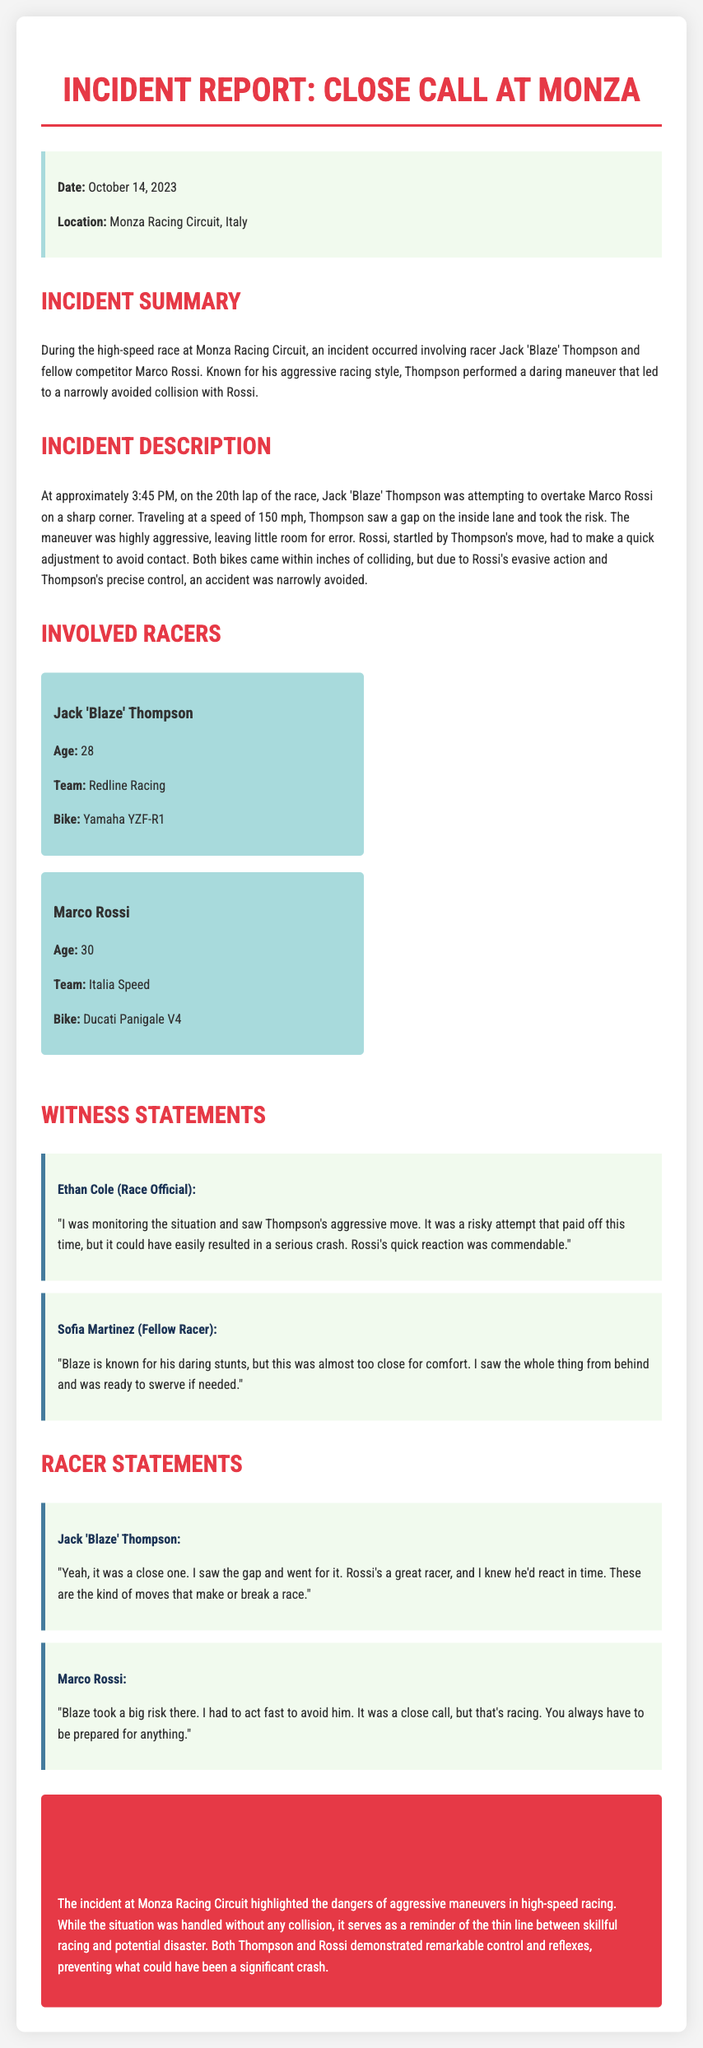What was the date of the incident? The date of the incident is explicitly mentioned in the document as October 14, 2023.
Answer: October 14, 2023 Who performed the aggressive maneuver? The report states that Jack 'Blaze' Thompson performed the aggressive maneuver during the race.
Answer: Jack 'Blaze' Thompson What was the speed of Thompson's bike during the incident? The document specifies that Thompson was traveling at a speed of 150 mph during the incident.
Answer: 150 mph Which team does Marco Rossi race for? According to the document, Marco Rossi is associated with the Italia Speed team.
Answer: Italia Speed What was the type of bike used by Jack 'Blaze' Thompson? The incident report identifies Thompson's bike as a Yamaha YZF-R1.
Answer: Yamaha YZF-R1 Why was the maneuver considered risky? The document explains that the maneuver left little room for error, making it highly aggressive and risky.
Answer: Little room for error What did Ethan Cole, the race official, say about the maneuver? Cole remarked that it was a risky attempt that could have resulted in a serious crash, but it paid off this time.
Answer: Risky attempt, serious crash What does the conclusion emphasize about the incident? The conclusion highlights the dangers of aggressive maneuvers in high-speed racing and the thin line between skillful racing and potential disaster.
Answer: Dangers of aggressive maneuvers How did Rossi react to Thompson's maneuver? The document mentions that Rossi had to make a quick adjustment to avoid contact with Thompson.
Answer: Quick adjustment 